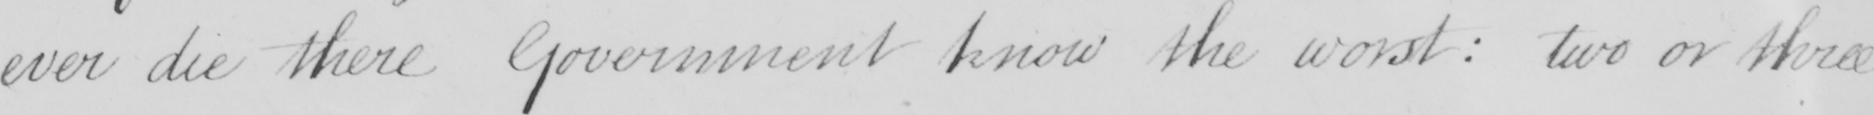What is written in this line of handwriting? ever die there Government know the worst :  two or three 